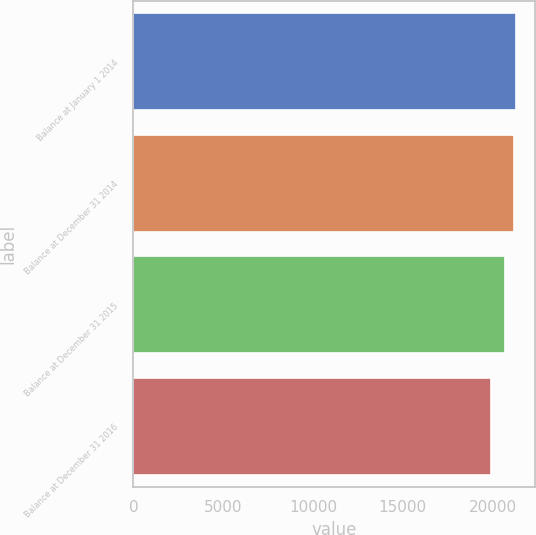Convert chart. <chart><loc_0><loc_0><loc_500><loc_500><bar_chart><fcel>Balance at January 1 2014<fcel>Balance at December 31 2014<fcel>Balance at December 31 2015<fcel>Balance at December 31 2016<nl><fcel>21318.3<fcel>21189<fcel>20702<fcel>19932<nl></chart> 